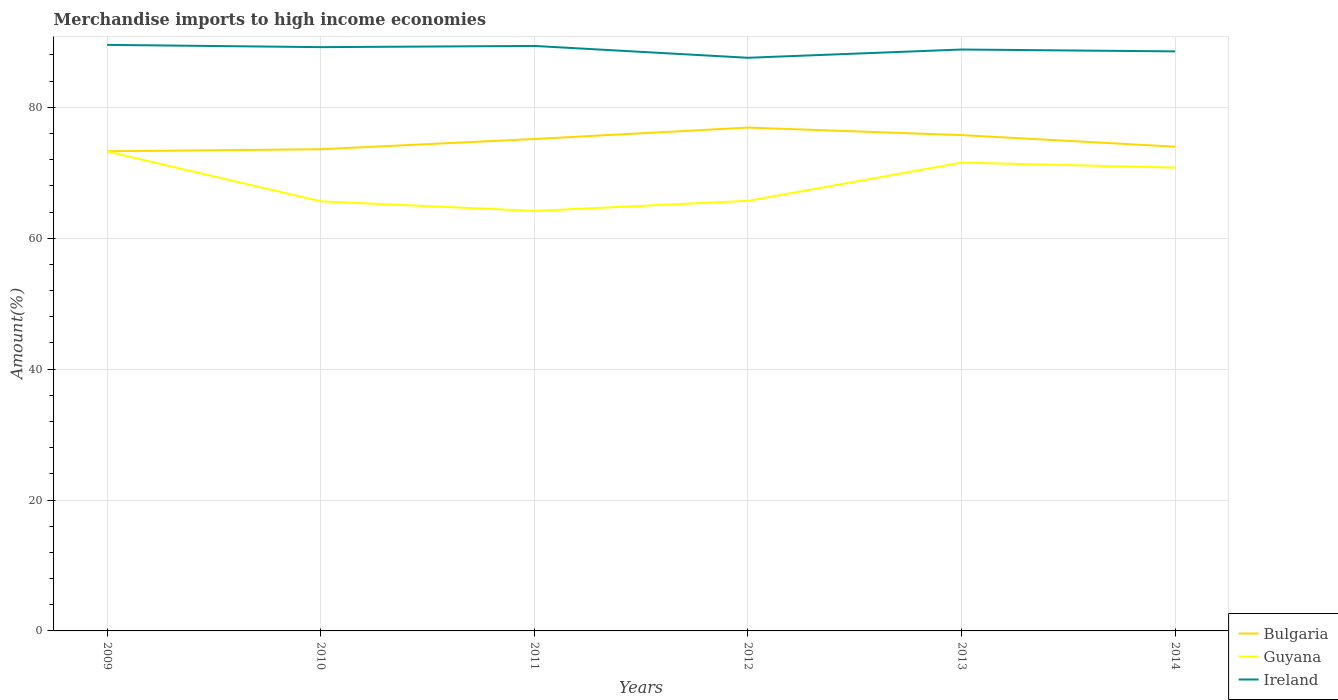Does the line corresponding to Bulgaria intersect with the line corresponding to Ireland?
Offer a very short reply. No. Is the number of lines equal to the number of legend labels?
Your answer should be compact. Yes. Across all years, what is the maximum percentage of amount earned from merchandise imports in Guyana?
Ensure brevity in your answer.  64.17. In which year was the percentage of amount earned from merchandise imports in Ireland maximum?
Offer a terse response. 2012. What is the total percentage of amount earned from merchandise imports in Bulgaria in the graph?
Give a very brief answer. 2.92. What is the difference between the highest and the second highest percentage of amount earned from merchandise imports in Ireland?
Your response must be concise. 1.97. Is the percentage of amount earned from merchandise imports in Ireland strictly greater than the percentage of amount earned from merchandise imports in Bulgaria over the years?
Your answer should be compact. No. How many lines are there?
Your response must be concise. 3. Are the values on the major ticks of Y-axis written in scientific E-notation?
Make the answer very short. No. Does the graph contain any zero values?
Your response must be concise. No. Does the graph contain grids?
Offer a very short reply. Yes. Where does the legend appear in the graph?
Offer a terse response. Bottom right. How are the legend labels stacked?
Ensure brevity in your answer.  Vertical. What is the title of the graph?
Your response must be concise. Merchandise imports to high income economies. Does "Fiji" appear as one of the legend labels in the graph?
Make the answer very short. No. What is the label or title of the X-axis?
Your response must be concise. Years. What is the label or title of the Y-axis?
Provide a succinct answer. Amount(%). What is the Amount(%) in Bulgaria in 2009?
Provide a succinct answer. 73.28. What is the Amount(%) of Guyana in 2009?
Ensure brevity in your answer.  73.25. What is the Amount(%) in Ireland in 2009?
Your answer should be compact. 89.54. What is the Amount(%) of Bulgaria in 2010?
Give a very brief answer. 73.59. What is the Amount(%) in Guyana in 2010?
Offer a terse response. 65.64. What is the Amount(%) in Ireland in 2010?
Ensure brevity in your answer.  89.19. What is the Amount(%) in Bulgaria in 2011?
Offer a very short reply. 75.16. What is the Amount(%) in Guyana in 2011?
Offer a terse response. 64.17. What is the Amount(%) of Ireland in 2011?
Provide a succinct answer. 89.37. What is the Amount(%) in Bulgaria in 2012?
Offer a terse response. 76.9. What is the Amount(%) in Guyana in 2012?
Provide a succinct answer. 65.71. What is the Amount(%) in Ireland in 2012?
Give a very brief answer. 87.57. What is the Amount(%) of Bulgaria in 2013?
Your answer should be compact. 75.75. What is the Amount(%) of Guyana in 2013?
Make the answer very short. 71.55. What is the Amount(%) in Ireland in 2013?
Your answer should be compact. 88.83. What is the Amount(%) in Bulgaria in 2014?
Your answer should be compact. 73.99. What is the Amount(%) of Guyana in 2014?
Your response must be concise. 70.79. What is the Amount(%) of Ireland in 2014?
Provide a short and direct response. 88.54. Across all years, what is the maximum Amount(%) in Bulgaria?
Offer a terse response. 76.9. Across all years, what is the maximum Amount(%) of Guyana?
Your answer should be compact. 73.25. Across all years, what is the maximum Amount(%) in Ireland?
Keep it short and to the point. 89.54. Across all years, what is the minimum Amount(%) of Bulgaria?
Your answer should be compact. 73.28. Across all years, what is the minimum Amount(%) of Guyana?
Keep it short and to the point. 64.17. Across all years, what is the minimum Amount(%) of Ireland?
Give a very brief answer. 87.57. What is the total Amount(%) in Bulgaria in the graph?
Provide a succinct answer. 448.67. What is the total Amount(%) of Guyana in the graph?
Your answer should be very brief. 411.1. What is the total Amount(%) of Ireland in the graph?
Your response must be concise. 533.04. What is the difference between the Amount(%) in Bulgaria in 2009 and that in 2010?
Your answer should be very brief. -0.31. What is the difference between the Amount(%) in Guyana in 2009 and that in 2010?
Your response must be concise. 7.61. What is the difference between the Amount(%) in Ireland in 2009 and that in 2010?
Give a very brief answer. 0.34. What is the difference between the Amount(%) in Bulgaria in 2009 and that in 2011?
Offer a terse response. -1.87. What is the difference between the Amount(%) of Guyana in 2009 and that in 2011?
Provide a succinct answer. 9.08. What is the difference between the Amount(%) in Ireland in 2009 and that in 2011?
Make the answer very short. 0.16. What is the difference between the Amount(%) in Bulgaria in 2009 and that in 2012?
Make the answer very short. -3.62. What is the difference between the Amount(%) of Guyana in 2009 and that in 2012?
Offer a very short reply. 7.54. What is the difference between the Amount(%) of Ireland in 2009 and that in 2012?
Your response must be concise. 1.97. What is the difference between the Amount(%) of Bulgaria in 2009 and that in 2013?
Your answer should be compact. -2.47. What is the difference between the Amount(%) of Guyana in 2009 and that in 2013?
Provide a succinct answer. 1.7. What is the difference between the Amount(%) in Ireland in 2009 and that in 2013?
Your response must be concise. 0.71. What is the difference between the Amount(%) of Bulgaria in 2009 and that in 2014?
Offer a terse response. -0.7. What is the difference between the Amount(%) in Guyana in 2009 and that in 2014?
Your answer should be compact. 2.46. What is the difference between the Amount(%) of Bulgaria in 2010 and that in 2011?
Provide a succinct answer. -1.56. What is the difference between the Amount(%) of Guyana in 2010 and that in 2011?
Keep it short and to the point. 1.47. What is the difference between the Amount(%) in Ireland in 2010 and that in 2011?
Ensure brevity in your answer.  -0.18. What is the difference between the Amount(%) in Bulgaria in 2010 and that in 2012?
Your response must be concise. -3.31. What is the difference between the Amount(%) in Guyana in 2010 and that in 2012?
Your answer should be compact. -0.07. What is the difference between the Amount(%) of Ireland in 2010 and that in 2012?
Ensure brevity in your answer.  1.63. What is the difference between the Amount(%) in Bulgaria in 2010 and that in 2013?
Keep it short and to the point. -2.16. What is the difference between the Amount(%) in Guyana in 2010 and that in 2013?
Your answer should be very brief. -5.91. What is the difference between the Amount(%) in Ireland in 2010 and that in 2013?
Ensure brevity in your answer.  0.36. What is the difference between the Amount(%) in Bulgaria in 2010 and that in 2014?
Provide a succinct answer. -0.39. What is the difference between the Amount(%) in Guyana in 2010 and that in 2014?
Provide a succinct answer. -5.15. What is the difference between the Amount(%) of Ireland in 2010 and that in 2014?
Provide a succinct answer. 0.65. What is the difference between the Amount(%) of Bulgaria in 2011 and that in 2012?
Keep it short and to the point. -1.75. What is the difference between the Amount(%) in Guyana in 2011 and that in 2012?
Your answer should be compact. -1.54. What is the difference between the Amount(%) of Ireland in 2011 and that in 2012?
Keep it short and to the point. 1.81. What is the difference between the Amount(%) in Bulgaria in 2011 and that in 2013?
Your response must be concise. -0.6. What is the difference between the Amount(%) in Guyana in 2011 and that in 2013?
Offer a terse response. -7.38. What is the difference between the Amount(%) in Ireland in 2011 and that in 2013?
Make the answer very short. 0.55. What is the difference between the Amount(%) in Bulgaria in 2011 and that in 2014?
Your answer should be compact. 1.17. What is the difference between the Amount(%) in Guyana in 2011 and that in 2014?
Provide a short and direct response. -6.62. What is the difference between the Amount(%) of Ireland in 2011 and that in 2014?
Offer a very short reply. 0.83. What is the difference between the Amount(%) of Bulgaria in 2012 and that in 2013?
Your answer should be very brief. 1.15. What is the difference between the Amount(%) in Guyana in 2012 and that in 2013?
Provide a short and direct response. -5.84. What is the difference between the Amount(%) in Ireland in 2012 and that in 2013?
Keep it short and to the point. -1.26. What is the difference between the Amount(%) in Bulgaria in 2012 and that in 2014?
Ensure brevity in your answer.  2.92. What is the difference between the Amount(%) of Guyana in 2012 and that in 2014?
Your response must be concise. -5.08. What is the difference between the Amount(%) in Ireland in 2012 and that in 2014?
Ensure brevity in your answer.  -0.98. What is the difference between the Amount(%) of Bulgaria in 2013 and that in 2014?
Offer a terse response. 1.77. What is the difference between the Amount(%) of Guyana in 2013 and that in 2014?
Your response must be concise. 0.76. What is the difference between the Amount(%) in Ireland in 2013 and that in 2014?
Your response must be concise. 0.29. What is the difference between the Amount(%) of Bulgaria in 2009 and the Amount(%) of Guyana in 2010?
Your response must be concise. 7.65. What is the difference between the Amount(%) in Bulgaria in 2009 and the Amount(%) in Ireland in 2010?
Give a very brief answer. -15.91. What is the difference between the Amount(%) in Guyana in 2009 and the Amount(%) in Ireland in 2010?
Ensure brevity in your answer.  -15.94. What is the difference between the Amount(%) of Bulgaria in 2009 and the Amount(%) of Guyana in 2011?
Make the answer very short. 9.11. What is the difference between the Amount(%) of Bulgaria in 2009 and the Amount(%) of Ireland in 2011?
Your answer should be very brief. -16.09. What is the difference between the Amount(%) in Guyana in 2009 and the Amount(%) in Ireland in 2011?
Make the answer very short. -16.13. What is the difference between the Amount(%) in Bulgaria in 2009 and the Amount(%) in Guyana in 2012?
Your answer should be compact. 7.57. What is the difference between the Amount(%) in Bulgaria in 2009 and the Amount(%) in Ireland in 2012?
Give a very brief answer. -14.28. What is the difference between the Amount(%) in Guyana in 2009 and the Amount(%) in Ireland in 2012?
Make the answer very short. -14.32. What is the difference between the Amount(%) in Bulgaria in 2009 and the Amount(%) in Guyana in 2013?
Your answer should be very brief. 1.73. What is the difference between the Amount(%) of Bulgaria in 2009 and the Amount(%) of Ireland in 2013?
Offer a very short reply. -15.55. What is the difference between the Amount(%) in Guyana in 2009 and the Amount(%) in Ireland in 2013?
Your answer should be very brief. -15.58. What is the difference between the Amount(%) in Bulgaria in 2009 and the Amount(%) in Guyana in 2014?
Make the answer very short. 2.5. What is the difference between the Amount(%) of Bulgaria in 2009 and the Amount(%) of Ireland in 2014?
Provide a succinct answer. -15.26. What is the difference between the Amount(%) of Guyana in 2009 and the Amount(%) of Ireland in 2014?
Ensure brevity in your answer.  -15.3. What is the difference between the Amount(%) in Bulgaria in 2010 and the Amount(%) in Guyana in 2011?
Offer a very short reply. 9.43. What is the difference between the Amount(%) of Bulgaria in 2010 and the Amount(%) of Ireland in 2011?
Offer a terse response. -15.78. What is the difference between the Amount(%) of Guyana in 2010 and the Amount(%) of Ireland in 2011?
Your answer should be compact. -23.74. What is the difference between the Amount(%) of Bulgaria in 2010 and the Amount(%) of Guyana in 2012?
Give a very brief answer. 7.88. What is the difference between the Amount(%) of Bulgaria in 2010 and the Amount(%) of Ireland in 2012?
Your response must be concise. -13.97. What is the difference between the Amount(%) in Guyana in 2010 and the Amount(%) in Ireland in 2012?
Make the answer very short. -21.93. What is the difference between the Amount(%) in Bulgaria in 2010 and the Amount(%) in Guyana in 2013?
Give a very brief answer. 2.04. What is the difference between the Amount(%) in Bulgaria in 2010 and the Amount(%) in Ireland in 2013?
Your answer should be compact. -15.24. What is the difference between the Amount(%) in Guyana in 2010 and the Amount(%) in Ireland in 2013?
Ensure brevity in your answer.  -23.19. What is the difference between the Amount(%) of Bulgaria in 2010 and the Amount(%) of Guyana in 2014?
Ensure brevity in your answer.  2.81. What is the difference between the Amount(%) of Bulgaria in 2010 and the Amount(%) of Ireland in 2014?
Provide a succinct answer. -14.95. What is the difference between the Amount(%) in Guyana in 2010 and the Amount(%) in Ireland in 2014?
Your answer should be compact. -22.91. What is the difference between the Amount(%) in Bulgaria in 2011 and the Amount(%) in Guyana in 2012?
Provide a short and direct response. 9.44. What is the difference between the Amount(%) in Bulgaria in 2011 and the Amount(%) in Ireland in 2012?
Your response must be concise. -12.41. What is the difference between the Amount(%) of Guyana in 2011 and the Amount(%) of Ireland in 2012?
Your answer should be compact. -23.4. What is the difference between the Amount(%) of Bulgaria in 2011 and the Amount(%) of Guyana in 2013?
Provide a short and direct response. 3.61. What is the difference between the Amount(%) of Bulgaria in 2011 and the Amount(%) of Ireland in 2013?
Your response must be concise. -13.67. What is the difference between the Amount(%) of Guyana in 2011 and the Amount(%) of Ireland in 2013?
Provide a short and direct response. -24.66. What is the difference between the Amount(%) in Bulgaria in 2011 and the Amount(%) in Guyana in 2014?
Offer a terse response. 4.37. What is the difference between the Amount(%) of Bulgaria in 2011 and the Amount(%) of Ireland in 2014?
Ensure brevity in your answer.  -13.39. What is the difference between the Amount(%) of Guyana in 2011 and the Amount(%) of Ireland in 2014?
Provide a short and direct response. -24.37. What is the difference between the Amount(%) of Bulgaria in 2012 and the Amount(%) of Guyana in 2013?
Your answer should be compact. 5.35. What is the difference between the Amount(%) in Bulgaria in 2012 and the Amount(%) in Ireland in 2013?
Offer a very short reply. -11.93. What is the difference between the Amount(%) in Guyana in 2012 and the Amount(%) in Ireland in 2013?
Your response must be concise. -23.12. What is the difference between the Amount(%) of Bulgaria in 2012 and the Amount(%) of Guyana in 2014?
Provide a succinct answer. 6.12. What is the difference between the Amount(%) of Bulgaria in 2012 and the Amount(%) of Ireland in 2014?
Your response must be concise. -11.64. What is the difference between the Amount(%) in Guyana in 2012 and the Amount(%) in Ireland in 2014?
Ensure brevity in your answer.  -22.83. What is the difference between the Amount(%) in Bulgaria in 2013 and the Amount(%) in Guyana in 2014?
Provide a short and direct response. 4.96. What is the difference between the Amount(%) of Bulgaria in 2013 and the Amount(%) of Ireland in 2014?
Ensure brevity in your answer.  -12.79. What is the difference between the Amount(%) in Guyana in 2013 and the Amount(%) in Ireland in 2014?
Provide a short and direct response. -16.99. What is the average Amount(%) of Bulgaria per year?
Ensure brevity in your answer.  74.78. What is the average Amount(%) of Guyana per year?
Your answer should be very brief. 68.52. What is the average Amount(%) in Ireland per year?
Make the answer very short. 88.84. In the year 2009, what is the difference between the Amount(%) in Bulgaria and Amount(%) in Guyana?
Your response must be concise. 0.03. In the year 2009, what is the difference between the Amount(%) in Bulgaria and Amount(%) in Ireland?
Provide a short and direct response. -16.26. In the year 2009, what is the difference between the Amount(%) of Guyana and Amount(%) of Ireland?
Keep it short and to the point. -16.29. In the year 2010, what is the difference between the Amount(%) of Bulgaria and Amount(%) of Guyana?
Your response must be concise. 7.96. In the year 2010, what is the difference between the Amount(%) of Bulgaria and Amount(%) of Ireland?
Your response must be concise. -15.6. In the year 2010, what is the difference between the Amount(%) in Guyana and Amount(%) in Ireland?
Offer a very short reply. -23.56. In the year 2011, what is the difference between the Amount(%) of Bulgaria and Amount(%) of Guyana?
Your response must be concise. 10.99. In the year 2011, what is the difference between the Amount(%) of Bulgaria and Amount(%) of Ireland?
Your answer should be compact. -14.22. In the year 2011, what is the difference between the Amount(%) in Guyana and Amount(%) in Ireland?
Your response must be concise. -25.21. In the year 2012, what is the difference between the Amount(%) of Bulgaria and Amount(%) of Guyana?
Make the answer very short. 11.19. In the year 2012, what is the difference between the Amount(%) in Bulgaria and Amount(%) in Ireland?
Your response must be concise. -10.66. In the year 2012, what is the difference between the Amount(%) of Guyana and Amount(%) of Ireland?
Your answer should be compact. -21.85. In the year 2013, what is the difference between the Amount(%) of Bulgaria and Amount(%) of Guyana?
Keep it short and to the point. 4.2. In the year 2013, what is the difference between the Amount(%) in Bulgaria and Amount(%) in Ireland?
Offer a very short reply. -13.08. In the year 2013, what is the difference between the Amount(%) in Guyana and Amount(%) in Ireland?
Provide a succinct answer. -17.28. In the year 2014, what is the difference between the Amount(%) in Bulgaria and Amount(%) in Guyana?
Give a very brief answer. 3.2. In the year 2014, what is the difference between the Amount(%) in Bulgaria and Amount(%) in Ireland?
Give a very brief answer. -14.56. In the year 2014, what is the difference between the Amount(%) in Guyana and Amount(%) in Ireland?
Make the answer very short. -17.76. What is the ratio of the Amount(%) of Guyana in 2009 to that in 2010?
Ensure brevity in your answer.  1.12. What is the ratio of the Amount(%) in Bulgaria in 2009 to that in 2011?
Keep it short and to the point. 0.98. What is the ratio of the Amount(%) of Guyana in 2009 to that in 2011?
Offer a very short reply. 1.14. What is the ratio of the Amount(%) of Ireland in 2009 to that in 2011?
Ensure brevity in your answer.  1. What is the ratio of the Amount(%) of Bulgaria in 2009 to that in 2012?
Your answer should be compact. 0.95. What is the ratio of the Amount(%) of Guyana in 2009 to that in 2012?
Keep it short and to the point. 1.11. What is the ratio of the Amount(%) of Ireland in 2009 to that in 2012?
Your answer should be very brief. 1.02. What is the ratio of the Amount(%) in Bulgaria in 2009 to that in 2013?
Your answer should be very brief. 0.97. What is the ratio of the Amount(%) of Guyana in 2009 to that in 2013?
Keep it short and to the point. 1.02. What is the ratio of the Amount(%) in Ireland in 2009 to that in 2013?
Keep it short and to the point. 1.01. What is the ratio of the Amount(%) in Guyana in 2009 to that in 2014?
Offer a terse response. 1.03. What is the ratio of the Amount(%) in Ireland in 2009 to that in 2014?
Your answer should be very brief. 1.01. What is the ratio of the Amount(%) of Bulgaria in 2010 to that in 2011?
Provide a short and direct response. 0.98. What is the ratio of the Amount(%) of Guyana in 2010 to that in 2011?
Keep it short and to the point. 1.02. What is the ratio of the Amount(%) in Guyana in 2010 to that in 2012?
Keep it short and to the point. 1. What is the ratio of the Amount(%) of Ireland in 2010 to that in 2012?
Give a very brief answer. 1.02. What is the ratio of the Amount(%) of Bulgaria in 2010 to that in 2013?
Offer a very short reply. 0.97. What is the ratio of the Amount(%) in Guyana in 2010 to that in 2013?
Your response must be concise. 0.92. What is the ratio of the Amount(%) of Guyana in 2010 to that in 2014?
Give a very brief answer. 0.93. What is the ratio of the Amount(%) in Ireland in 2010 to that in 2014?
Offer a very short reply. 1.01. What is the ratio of the Amount(%) of Bulgaria in 2011 to that in 2012?
Offer a very short reply. 0.98. What is the ratio of the Amount(%) in Guyana in 2011 to that in 2012?
Give a very brief answer. 0.98. What is the ratio of the Amount(%) in Ireland in 2011 to that in 2012?
Provide a succinct answer. 1.02. What is the ratio of the Amount(%) in Guyana in 2011 to that in 2013?
Ensure brevity in your answer.  0.9. What is the ratio of the Amount(%) of Ireland in 2011 to that in 2013?
Offer a very short reply. 1.01. What is the ratio of the Amount(%) in Bulgaria in 2011 to that in 2014?
Ensure brevity in your answer.  1.02. What is the ratio of the Amount(%) of Guyana in 2011 to that in 2014?
Make the answer very short. 0.91. What is the ratio of the Amount(%) in Ireland in 2011 to that in 2014?
Your answer should be very brief. 1.01. What is the ratio of the Amount(%) in Bulgaria in 2012 to that in 2013?
Keep it short and to the point. 1.02. What is the ratio of the Amount(%) in Guyana in 2012 to that in 2013?
Your answer should be compact. 0.92. What is the ratio of the Amount(%) of Ireland in 2012 to that in 2013?
Your answer should be very brief. 0.99. What is the ratio of the Amount(%) in Bulgaria in 2012 to that in 2014?
Provide a short and direct response. 1.04. What is the ratio of the Amount(%) in Guyana in 2012 to that in 2014?
Your answer should be very brief. 0.93. What is the ratio of the Amount(%) of Ireland in 2012 to that in 2014?
Your answer should be compact. 0.99. What is the ratio of the Amount(%) in Bulgaria in 2013 to that in 2014?
Provide a succinct answer. 1.02. What is the ratio of the Amount(%) of Guyana in 2013 to that in 2014?
Provide a succinct answer. 1.01. What is the ratio of the Amount(%) in Ireland in 2013 to that in 2014?
Your answer should be compact. 1. What is the difference between the highest and the second highest Amount(%) in Bulgaria?
Offer a terse response. 1.15. What is the difference between the highest and the second highest Amount(%) in Guyana?
Keep it short and to the point. 1.7. What is the difference between the highest and the second highest Amount(%) of Ireland?
Your answer should be compact. 0.16. What is the difference between the highest and the lowest Amount(%) in Bulgaria?
Give a very brief answer. 3.62. What is the difference between the highest and the lowest Amount(%) in Guyana?
Your answer should be very brief. 9.08. What is the difference between the highest and the lowest Amount(%) in Ireland?
Make the answer very short. 1.97. 